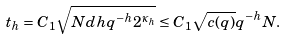Convert formula to latex. <formula><loc_0><loc_0><loc_500><loc_500>t _ { h } = C _ { 1 } \sqrt { N d h q ^ { - h } 2 ^ { \kappa _ { h } } } \leq C _ { 1 } \sqrt { c ( q ) } q ^ { - h } N .</formula> 